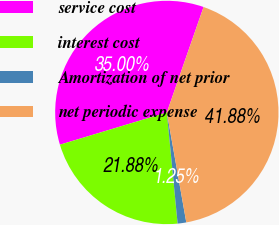<chart> <loc_0><loc_0><loc_500><loc_500><pie_chart><fcel>service cost<fcel>interest cost<fcel>Amortization of net prior<fcel>net periodic expense<nl><fcel>35.0%<fcel>21.88%<fcel>1.25%<fcel>41.88%<nl></chart> 